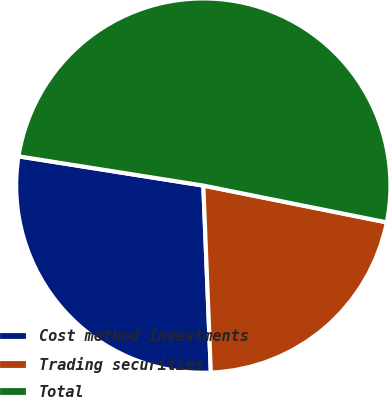Convert chart to OTSL. <chart><loc_0><loc_0><loc_500><loc_500><pie_chart><fcel>Cost method investments<fcel>Trading securities<fcel>Total<nl><fcel>28.14%<fcel>21.21%<fcel>50.65%<nl></chart> 